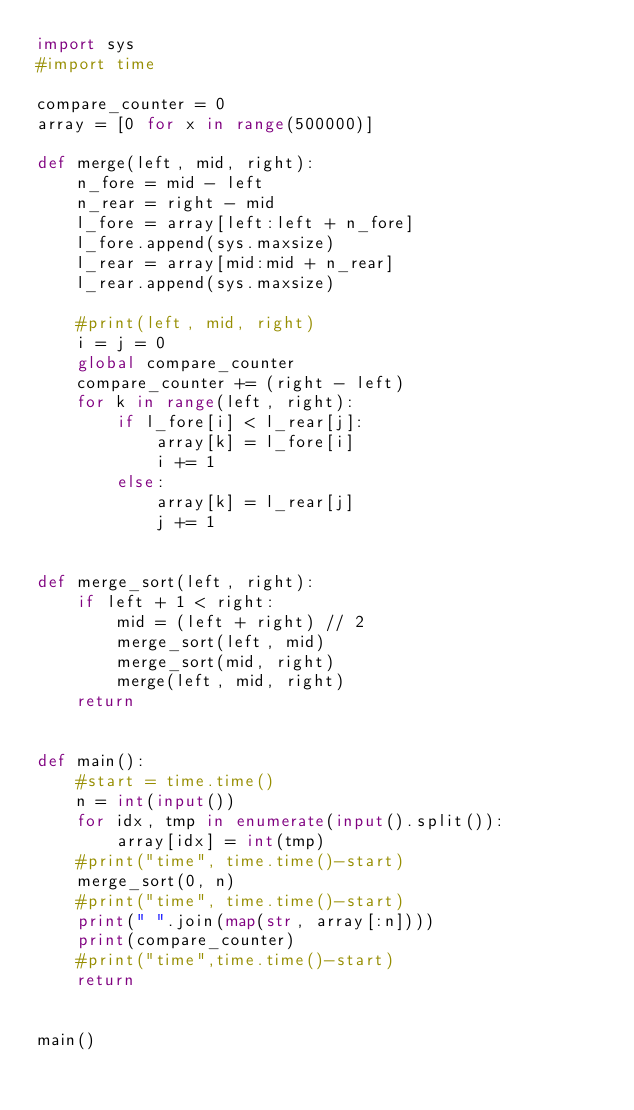Convert code to text. <code><loc_0><loc_0><loc_500><loc_500><_Python_>import sys
#import time

compare_counter = 0
array = [0 for x in range(500000)]

def merge(left, mid, right):
    n_fore = mid - left
    n_rear = right - mid
    l_fore = array[left:left + n_fore]
    l_fore.append(sys.maxsize)
    l_rear = array[mid:mid + n_rear]
    l_rear.append(sys.maxsize)

    #print(left, mid, right)
    i = j = 0
    global compare_counter
    compare_counter += (right - left)
    for k in range(left, right):
        if l_fore[i] < l_rear[j]:
            array[k] = l_fore[i]
            i += 1
        else:
            array[k] = l_rear[j]
            j += 1


def merge_sort(left, right):
    if left + 1 < right:
        mid = (left + right) // 2
        merge_sort(left, mid)
        merge_sort(mid, right)
        merge(left, mid, right)
    return


def main():
    #start = time.time()
    n = int(input())
    for idx, tmp in enumerate(input().split()):
        array[idx] = int(tmp)
    #print("time", time.time()-start)
    merge_sort(0, n)
    #print("time", time.time()-start)
    print(" ".join(map(str, array[:n])))
    print(compare_counter)
    #print("time",time.time()-start)
    return


main()
</code> 